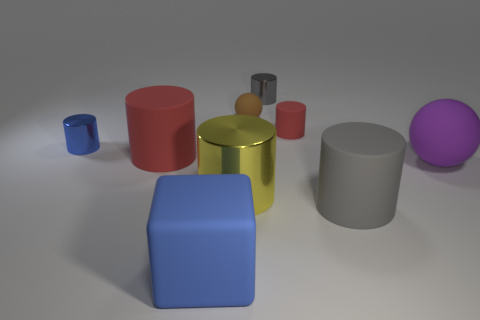Subtract all red blocks. How many red cylinders are left? 2 Subtract all blue cylinders. How many cylinders are left? 5 Subtract all tiny red cylinders. How many cylinders are left? 5 Subtract all red cylinders. Subtract all blue cubes. How many cylinders are left? 4 Subtract all blocks. How many objects are left? 8 Add 1 gray rubber cylinders. How many gray rubber cylinders are left? 2 Add 2 big cylinders. How many big cylinders exist? 5 Subtract 0 red balls. How many objects are left? 9 Subtract all tiny blue matte cylinders. Subtract all yellow objects. How many objects are left? 8 